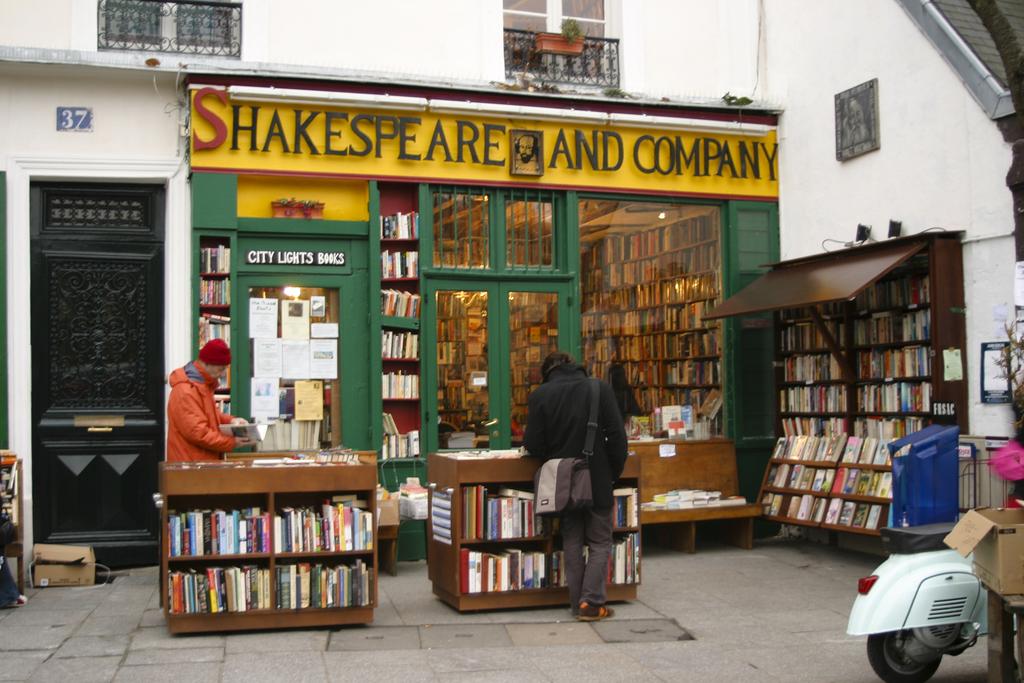What is the name of the book store?
Give a very brief answer. Shakespeare and company. What number is above the door?
Provide a short and direct response. 37. 